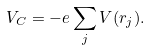Convert formula to latex. <formula><loc_0><loc_0><loc_500><loc_500>V _ { C } = - e \sum _ { j } V ( r _ { j } ) .</formula> 